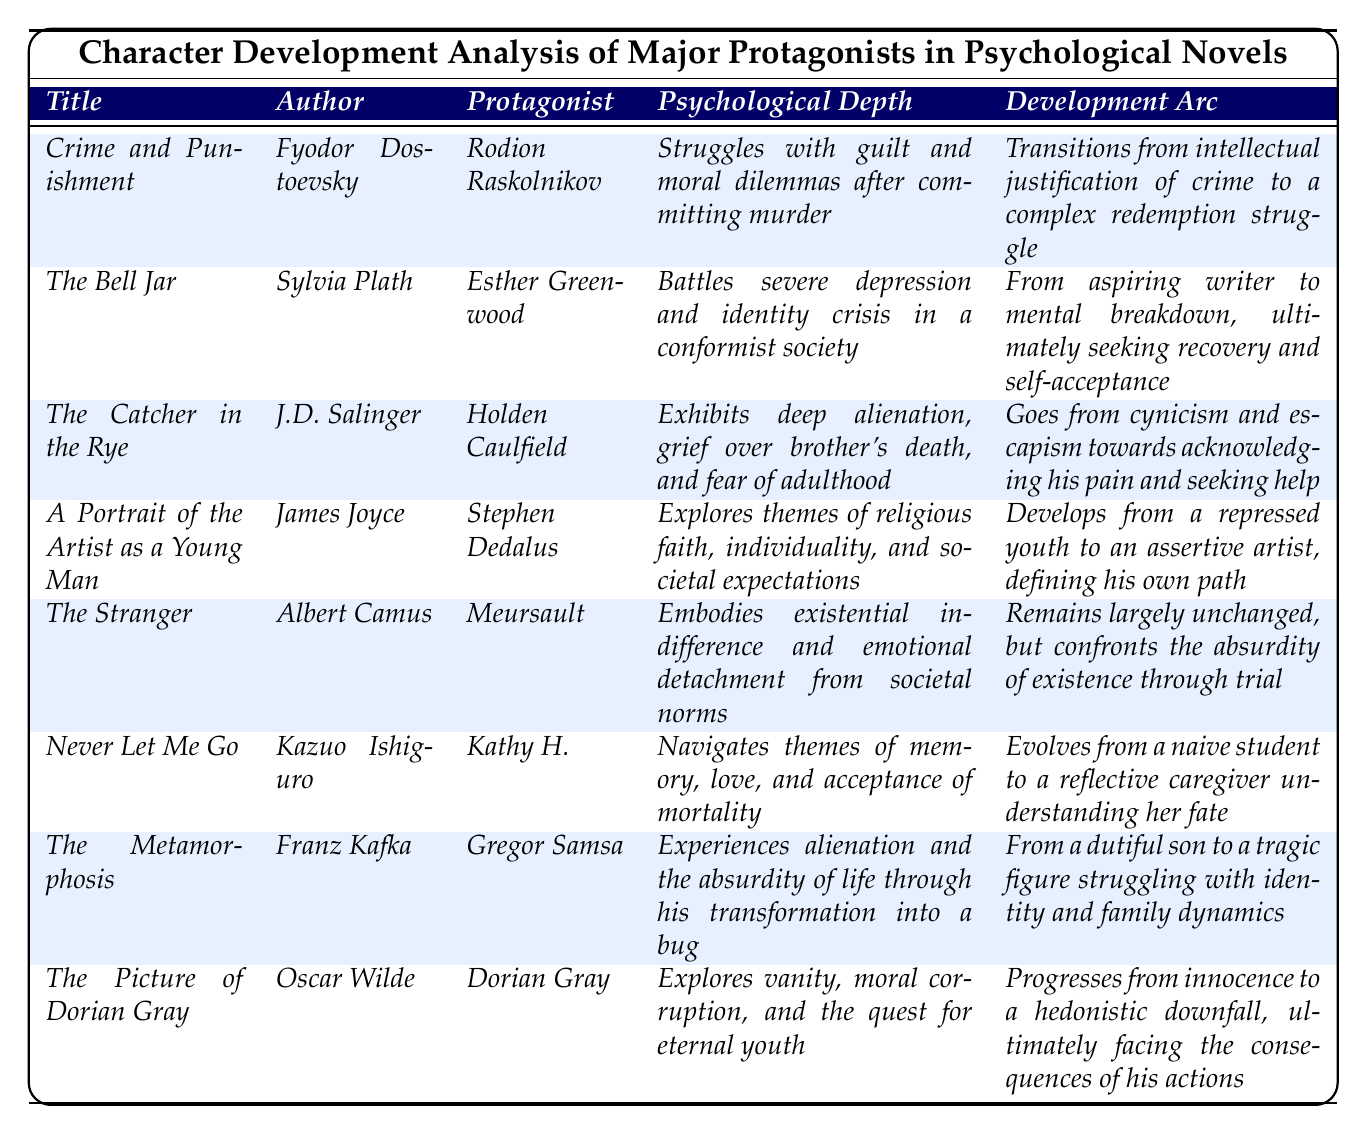What is the psychological depth of *Kathy H.* in *Never Let Me Go*? The table indicates that Kathy H. navigates themes of memory, love, and acceptance of mortality.
Answer: Navigates themes of memory, love, and acceptance of mortality Who is the author of *The Catcher in the Rye*? The author listed in the table next to *The Catcher in the Rye* is J.D. Salinger.
Answer: J.D. Salinger Which protagonist experiences alienation through his transformation into a bug? The table shows that Gregor Samsa is the protagonist who experiences alienation and absurdity from his transformation into a bug in *The Metamorphosis*.
Answer: Gregor Samsa Does *Dorian Gray* undergo a significant change throughout the novel? Reviewing the development arc for Dorian Gray in the table, it states that he progresses from innocence to a hedonistic downfall, indicating significant change.
Answer: Yes What is the common theme experienced by both *Holden Caulfield* and *Esther Greenwood*? Both characters face personal struggles; Holden deals with alienation and grief while Esther confronts severe depression, suggesting a common theme of mental struggle and identity crisis.
Answer: Mental struggle and identity crisis How many protagonists exhibit an unchanged development arc according to the table? The table indicates that only one protagonist, *Meursault* from *The Stranger*, remains largely unchanged, highlighting a unique development arc compared to others.
Answer: One Which protagonist transitions from a repressed youth to an assertive artist? The table indicates that Stephen Dedalus from *A Portrait of the Artist as a Young Man* develops from a repressed youth to an assertive artist.
Answer: Stephen Dedalus In terms of psychological depth, which protagonist deals with guilt and moral dilemmas? The entry for *Crime and Punishment* highlights Rodion Raskolnikov, who struggles with guilt and moral dilemmas after committing murder.
Answer: Rodion Raskolnikov What is the overall development arc of *Kathy H.* as listed in the table? According to the table, Kathy H. evolves from a naive student to a reflective caregiver understanding her fate, showcasing a significant character development arc.
Answer: Evolves from naive student to reflective caregiver Which novel features a protagonist confronting the absurdity of existence? The table defines the protagonist Meursault in *The Stranger* as embodying existential indifference and confronting absurdity.
Answer: *The Stranger* 